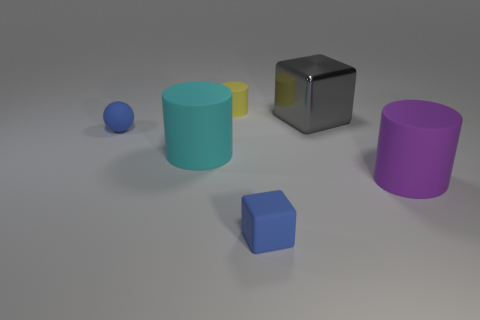There is a blue object in front of the purple matte thing; what is it made of?
Your response must be concise. Rubber. Are there any blue objects to the right of the large gray cube?
Ensure brevity in your answer.  No. Do the cyan rubber object and the ball have the same size?
Ensure brevity in your answer.  No. How many small blue blocks are made of the same material as the tiny sphere?
Ensure brevity in your answer.  1. What is the size of the blue matte object in front of the big rubber cylinder that is to the right of the big shiny object?
Your response must be concise. Small. There is a rubber thing that is both on the right side of the rubber sphere and on the left side of the tiny cylinder; what is its color?
Provide a short and direct response. Cyan. Is the metal object the same shape as the cyan rubber thing?
Your response must be concise. No. There is a matte object that is the same color as the matte cube; what size is it?
Your answer should be very brief. Small. There is a small rubber object that is in front of the purple thing that is in front of the small blue ball; what is its shape?
Ensure brevity in your answer.  Cube. There is a large cyan thing; is it the same shape as the small blue matte object that is left of the tiny blue cube?
Keep it short and to the point. No. 